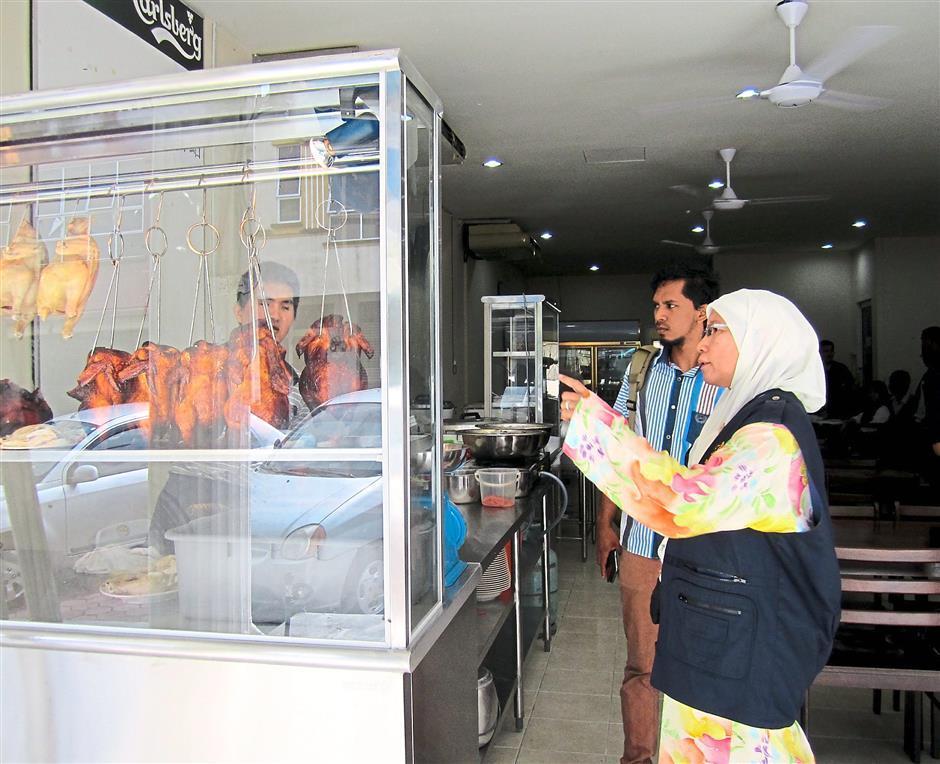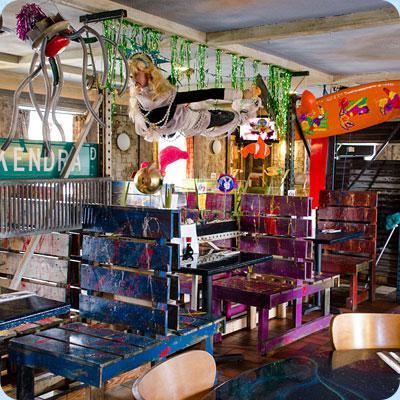The first image is the image on the left, the second image is the image on the right. For the images displayed, is the sentence "Two people are standing in front of a food vendor in the image on the left." factually correct? Answer yes or no. Yes. 